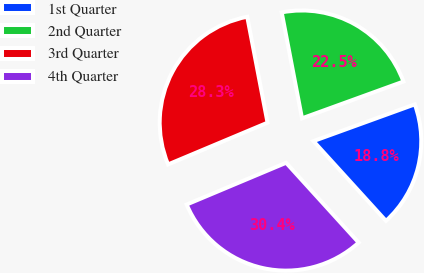Convert chart to OTSL. <chart><loc_0><loc_0><loc_500><loc_500><pie_chart><fcel>1st Quarter<fcel>2nd Quarter<fcel>3rd Quarter<fcel>4th Quarter<nl><fcel>18.79%<fcel>22.48%<fcel>28.31%<fcel>30.42%<nl></chart> 